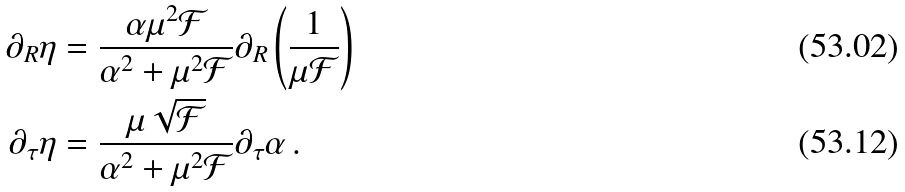Convert formula to latex. <formula><loc_0><loc_0><loc_500><loc_500>\partial _ { R } \eta & = \frac { \alpha \mu ^ { 2 } \mathcal { F } } { \alpha ^ { 2 } + \mu ^ { 2 } \mathcal { F } } \partial _ { R } \left ( \frac { 1 } { \mu \mathcal { F } } \right ) \\ \partial _ { \tau } \eta & = \frac { \mu \sqrt { \mathcal { F } } } { \alpha ^ { 2 } + \mu ^ { 2 } \mathcal { F } } \partial _ { \tau } \alpha \, .</formula> 